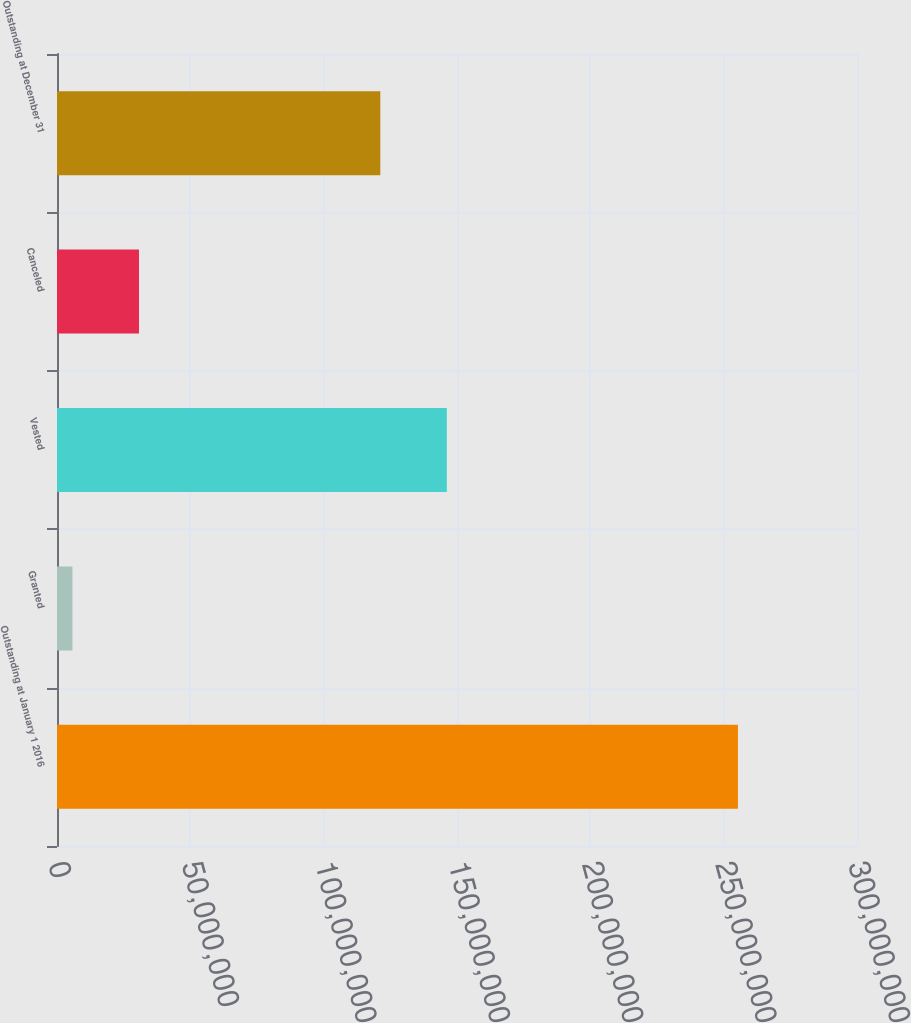Convert chart to OTSL. <chart><loc_0><loc_0><loc_500><loc_500><bar_chart><fcel>Outstanding at January 1 2016<fcel>Granted<fcel>Vested<fcel>Canceled<fcel>Outstanding at December 31<nl><fcel>2.55355e+08<fcel>5.78749e+06<fcel>1.46192e+08<fcel>3.07442e+07<fcel>1.21235e+08<nl></chart> 